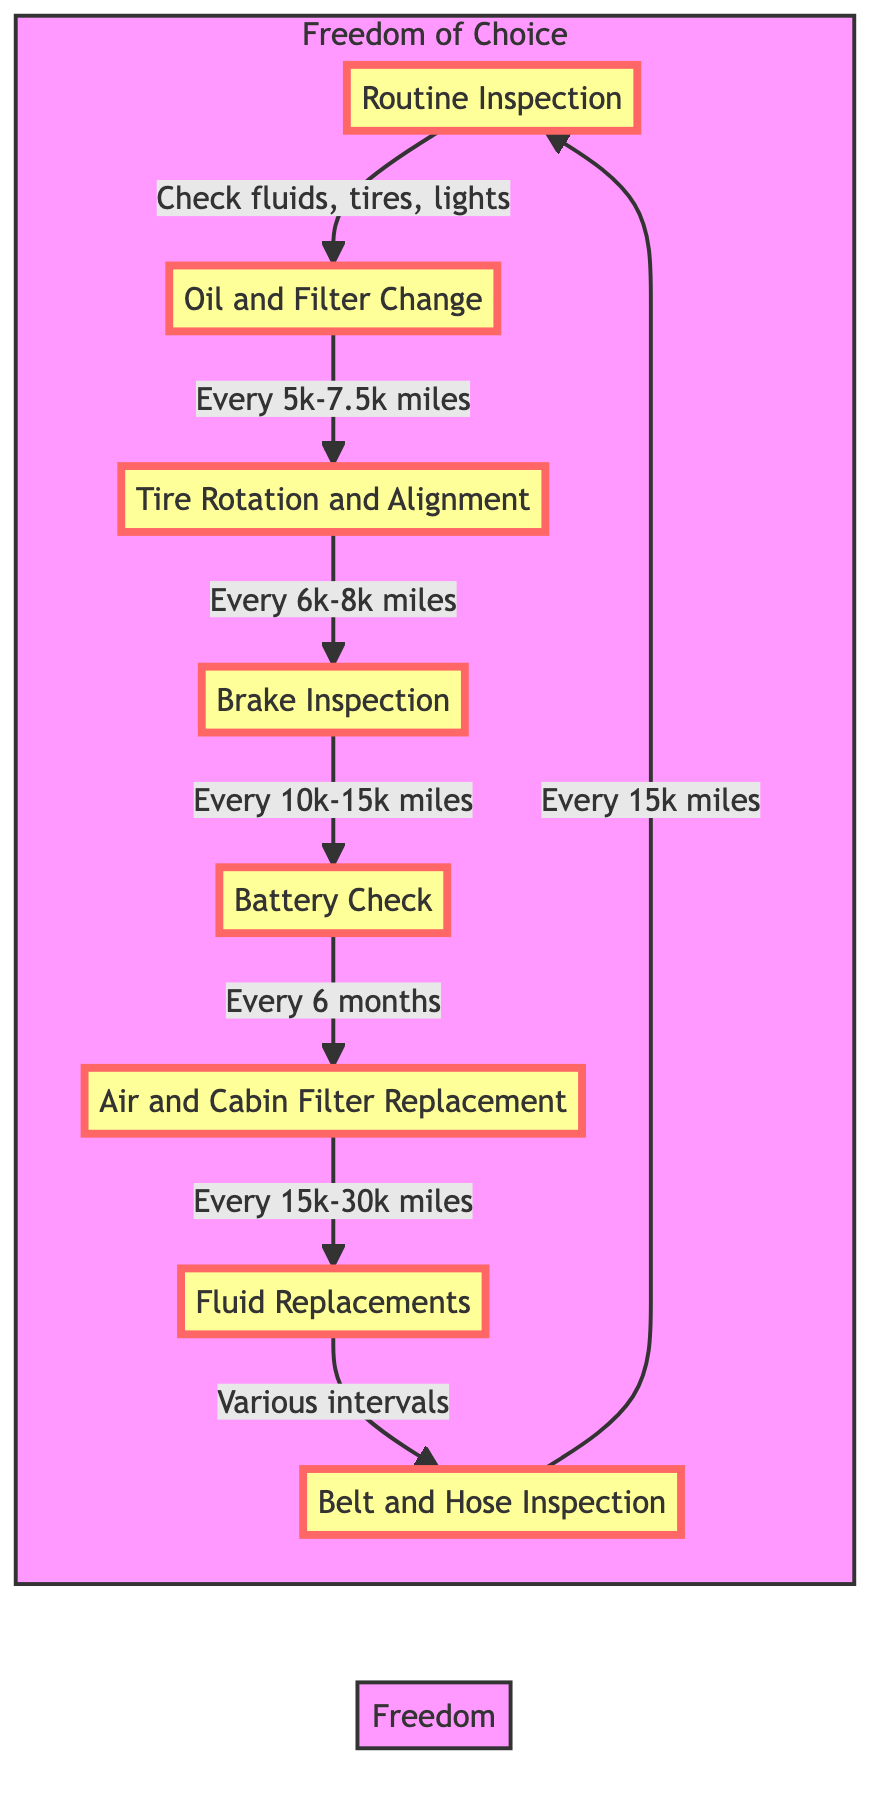What is the first step in the maintenance schedule? The first step listed in the flowchart is "Routine Inspection," indicating that it is the starting point of the maintenance schedule.
Answer: Routine Inspection How often should the oil and filter be changed? The flowchart specifies that the oil and filter should be changed every 5,000 to 7,500 miles, which is clearly listed under the "Oil and Filter Change" step.
Answer: Every 5,000 to 7,500 miles What is the interval for tire rotation and alignment? According to the flowchart, tire rotation should occur every 6,000 to 8,000 miles, and this information is found in the "Tire Rotation and Alignment" step.
Answer: Every 6,000 to 8,000 miles What maintenance step occurs every 10,000 to 15,000 miles? The "Brake Inspection" step in the flowchart states that the inspection should be conducted every 10,000 to 15,000 miles.
Answer: Brake Inspection Which maintenance step is performed every 6 months? The "Battery Check" step indicates that this inspection should happen every 6 months, as mentioned in its details.
Answer: Every 6 months How many steps are listed in the maintenance schedule? By counting the nodes in the flowchart, there are a total of 8 steps identified in the personal car maintenance schedule.
Answer: 8 Which step follows the brake inspection in the flowchart? Reviewing the order in the flowchart, after "Brake Inspection," the next step indicated is "Battery Check."
Answer: Battery Check What is the last step before returning to routine inspection? The flowchart shows that "Belt and Hose Inspection" is the last step before connecting back to the "Routine Inspection" step in the cycle.
Answer: Belt and Hose Inspection What should the air and cabin filter replacement interval be? The indicated interval for both air and cabin filter replacement is noted in the flowchart as every 15,000 to 30,000 miles for the air filter and every 15,000 to 20,000 miles for the cabin filter.
Answer: Every 15,000 to 30,000 miles, Every 15,000 to 20,000 miles What is checked during the routine inspection? The flowchart specifies that the routine inspection involves checking fluid levels, tire pressure, and lights, providing a clear overview of the initial maintenance tasks.
Answer: Fluid levels, tire pressure, and lights 